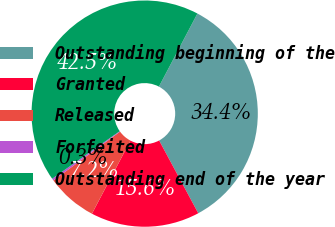Convert chart to OTSL. <chart><loc_0><loc_0><loc_500><loc_500><pie_chart><fcel>Outstanding beginning of the<fcel>Granted<fcel>Released<fcel>Forfeited<fcel>Outstanding end of the year<nl><fcel>34.43%<fcel>15.57%<fcel>7.23%<fcel>0.29%<fcel>42.48%<nl></chart> 